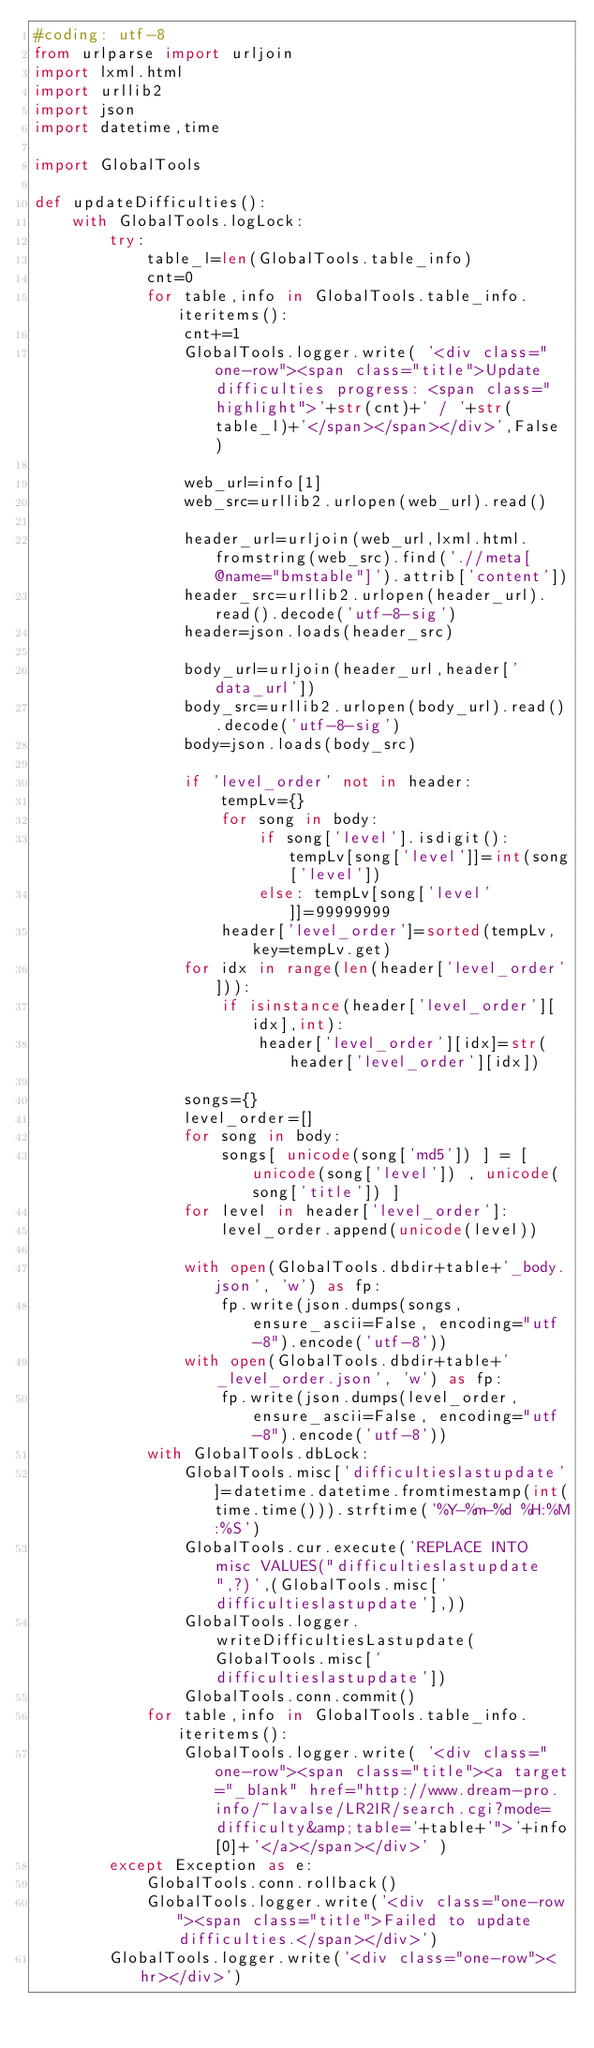Convert code to text. <code><loc_0><loc_0><loc_500><loc_500><_Python_>#coding: utf-8
from urlparse import urljoin
import lxml.html
import urllib2
import json
import datetime,time

import GlobalTools

def updateDifficulties():
	with GlobalTools.logLock:
		try:
			table_l=len(GlobalTools.table_info)
			cnt=0
			for table,info in GlobalTools.table_info.iteritems():
				cnt+=1
				GlobalTools.logger.write( '<div class="one-row"><span class="title">Update difficulties progress: <span class="highlight">'+str(cnt)+' / '+str(table_l)+'</span></span></div>',False )
				
				web_url=info[1]
				web_src=urllib2.urlopen(web_url).read()
				
				header_url=urljoin(web_url,lxml.html.fromstring(web_src).find('.//meta[@name="bmstable"]').attrib['content'])
				header_src=urllib2.urlopen(header_url).read().decode('utf-8-sig')
				header=json.loads(header_src)
				
				body_url=urljoin(header_url,header['data_url'])
				body_src=urllib2.urlopen(body_url).read().decode('utf-8-sig')
				body=json.loads(body_src)
				
				if 'level_order' not in header:
					tempLv={}
					for song in body:
						if song['level'].isdigit(): tempLv[song['level']]=int(song['level'])
						else: tempLv[song['level']]=99999999
					header['level_order']=sorted(tempLv, key=tempLv.get)
				for idx in range(len(header['level_order'])):
					if isinstance(header['level_order'][idx],int):
						header['level_order'][idx]=str(header['level_order'][idx])
				
				songs={}
				level_order=[]
				for song in body:
					songs[ unicode(song['md5']) ] = [ unicode(song['level']) , unicode(song['title']) ]
				for level in header['level_order']:
					level_order.append(unicode(level))
				
				with open(GlobalTools.dbdir+table+'_body.json', 'w') as fp:
					fp.write(json.dumps(songs, ensure_ascii=False, encoding="utf-8").encode('utf-8'))
				with open(GlobalTools.dbdir+table+'_level_order.json', 'w') as fp:
					fp.write(json.dumps(level_order, ensure_ascii=False, encoding="utf-8").encode('utf-8'))
			with GlobalTools.dbLock:
				GlobalTools.misc['difficultieslastupdate']=datetime.datetime.fromtimestamp(int(time.time())).strftime('%Y-%m-%d %H:%M:%S')
				GlobalTools.cur.execute('REPLACE INTO misc VALUES("difficultieslastupdate",?)',(GlobalTools.misc['difficultieslastupdate'],))
				GlobalTools.logger.writeDifficultiesLastupdate(GlobalTools.misc['difficultieslastupdate'])
				GlobalTools.conn.commit()
			for table,info in GlobalTools.table_info.iteritems():
				GlobalTools.logger.write( '<div class="one-row"><span class="title"><a target="_blank" href="http://www.dream-pro.info/~lavalse/LR2IR/search.cgi?mode=difficulty&amp;table='+table+'">'+info[0]+'</a></span></div>' )
		except Exception as e:
			GlobalTools.conn.rollback()
			GlobalTools.logger.write('<div class="one-row"><span class="title">Failed to update difficulties.</span></div>')
		GlobalTools.logger.write('<div class="one-row"><hr></div>')</code> 